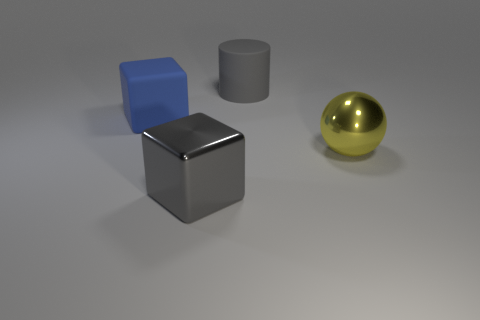Add 4 big blue matte cylinders. How many objects exist? 8 Subtract all cylinders. How many objects are left? 3 Add 1 matte cylinders. How many matte cylinders exist? 2 Subtract 0 cyan cylinders. How many objects are left? 4 Subtract all large blue things. Subtract all large blue things. How many objects are left? 2 Add 4 yellow objects. How many yellow objects are left? 5 